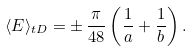Convert formula to latex. <formula><loc_0><loc_0><loc_500><loc_500>\langle E \rangle _ { t D } = \pm \, \frac { \pi } { 4 8 } \left ( \frac { 1 } { a } + \frac { 1 } { b } \right ) .</formula> 